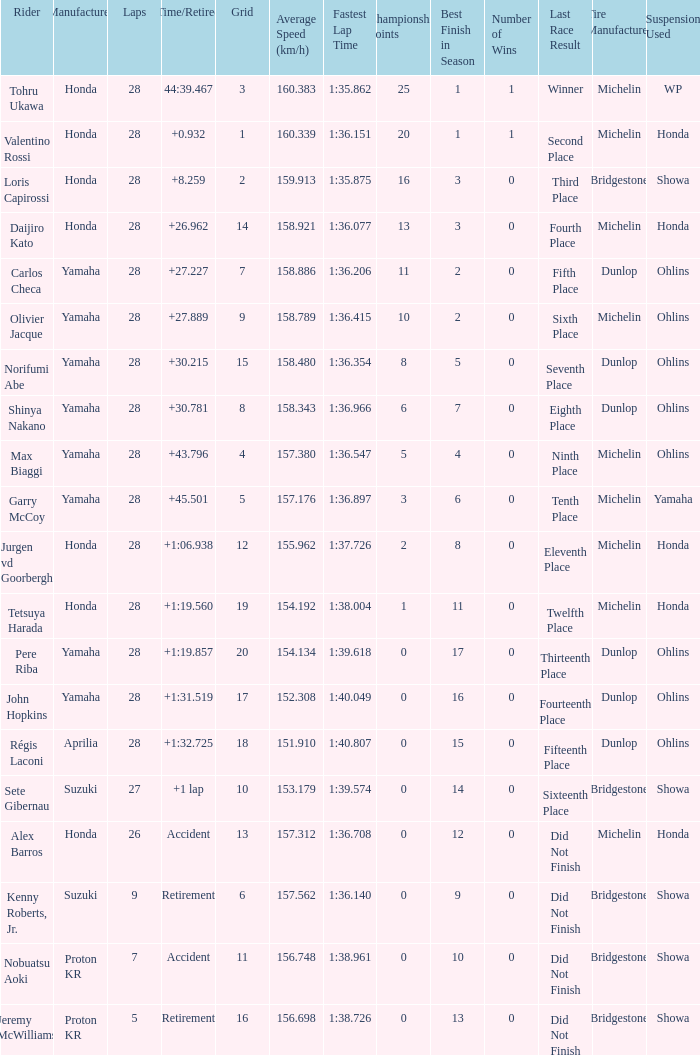How many laps were in grid 4? 28.0. 